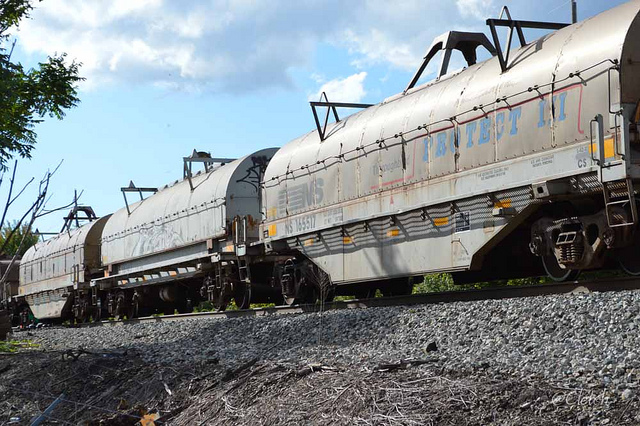Please identify all text content in this image. PBOTECT III 